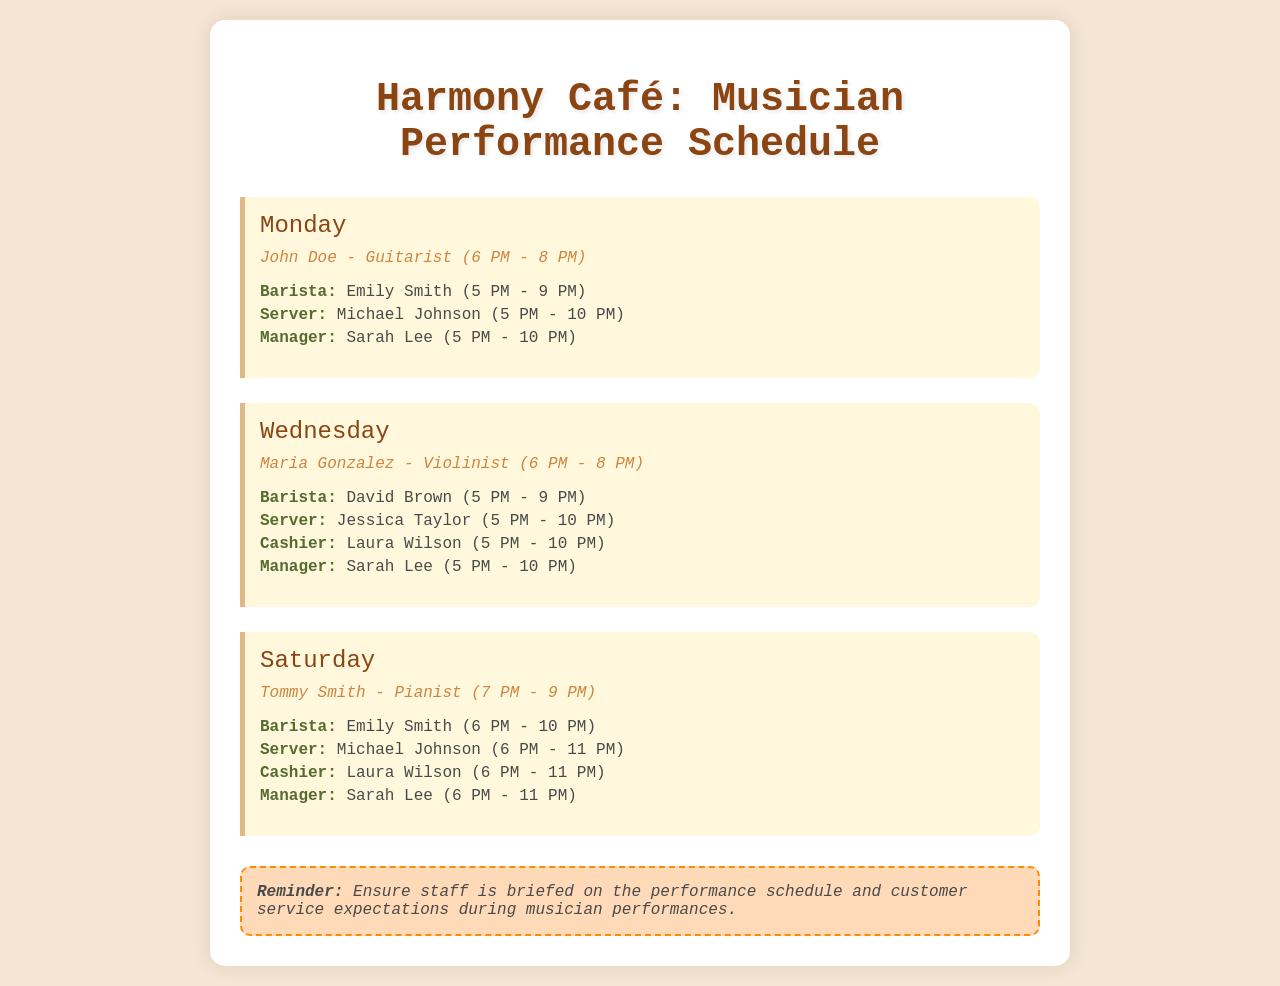What time does John Doe perform? John Doe performs from 6 PM to 8 PM on Monday, as indicated in the schedule.
Answer: 6 PM - 8 PM Who is the cashier on Wednesday? The cashier listed for Wednesday is Laura Wilson, mentioned in the staff list for that day.
Answer: Laura Wilson Which musician performs on Saturday? The schedule states that Tommy Smith performs as a pianist on Saturday.
Answer: Tommy Smith What are the working hours for the server on Monday? The working hours for the server on Monday, Michael Johnson, are from 5 PM to 10 PM, as detailed in the staff list.
Answer: 5 PM - 10 PM How many staff members are scheduled for Wednesday? The staff list for Wednesday includes four members: a barista, a server, a cashier, and a manager.
Answer: Four What role does Emily Smith have on Saturday? Emily Smith's role on Saturday is a barista, as specified in the staff list.
Answer: Barista What is the reminder about? The reminder emphasizes briefing staff on performance schedules and customer service expectations during musician performances.
Answer: Staff briefing At what time does the café open on Saturday with live music? The café operates with live music starting at 7 PM on Saturday as per the musician performance schedule.
Answer: 7 PM 